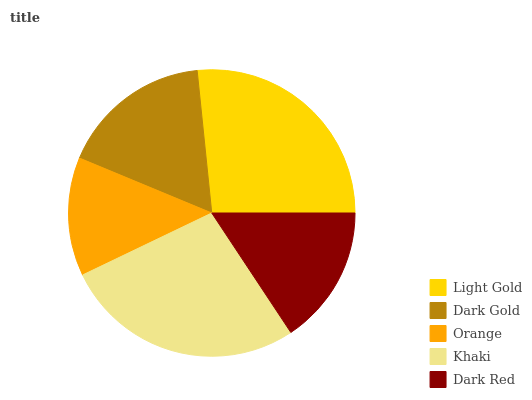Is Orange the minimum?
Answer yes or no. Yes. Is Khaki the maximum?
Answer yes or no. Yes. Is Dark Gold the minimum?
Answer yes or no. No. Is Dark Gold the maximum?
Answer yes or no. No. Is Light Gold greater than Dark Gold?
Answer yes or no. Yes. Is Dark Gold less than Light Gold?
Answer yes or no. Yes. Is Dark Gold greater than Light Gold?
Answer yes or no. No. Is Light Gold less than Dark Gold?
Answer yes or no. No. Is Dark Gold the high median?
Answer yes or no. Yes. Is Dark Gold the low median?
Answer yes or no. Yes. Is Light Gold the high median?
Answer yes or no. No. Is Orange the low median?
Answer yes or no. No. 